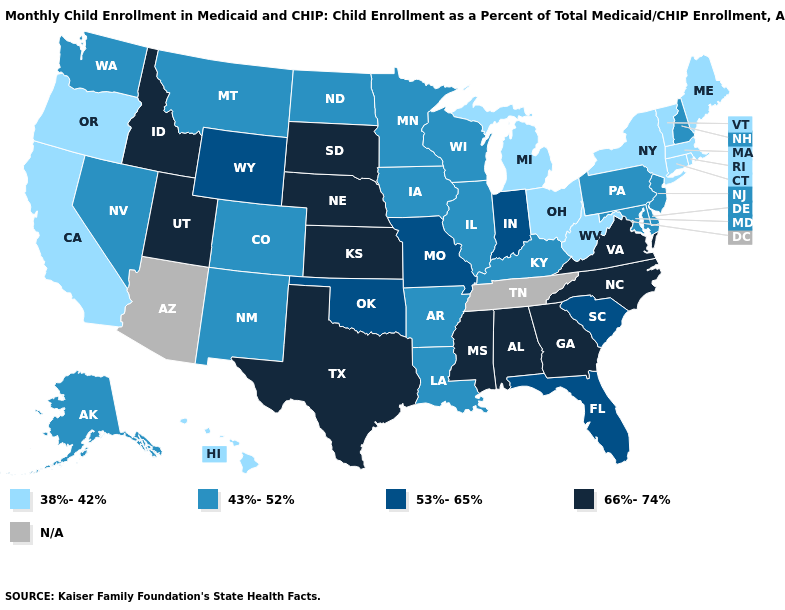What is the value of Missouri?
Answer briefly. 53%-65%. Name the states that have a value in the range N/A?
Keep it brief. Arizona, Tennessee. Does Kansas have the highest value in the USA?
Give a very brief answer. Yes. What is the value of Oklahoma?
Answer briefly. 53%-65%. What is the value of Wyoming?
Give a very brief answer. 53%-65%. Name the states that have a value in the range 53%-65%?
Give a very brief answer. Florida, Indiana, Missouri, Oklahoma, South Carolina, Wyoming. Name the states that have a value in the range 43%-52%?
Be succinct. Alaska, Arkansas, Colorado, Delaware, Illinois, Iowa, Kentucky, Louisiana, Maryland, Minnesota, Montana, Nevada, New Hampshire, New Jersey, New Mexico, North Dakota, Pennsylvania, Washington, Wisconsin. Among the states that border Iowa , does Missouri have the lowest value?
Give a very brief answer. No. What is the value of Wyoming?
Give a very brief answer. 53%-65%. What is the value of Missouri?
Write a very short answer. 53%-65%. Does the map have missing data?
Concise answer only. Yes. What is the highest value in the USA?
Short answer required. 66%-74%. What is the value of Ohio?
Be succinct. 38%-42%. Does Mississippi have the lowest value in the South?
Write a very short answer. No. 